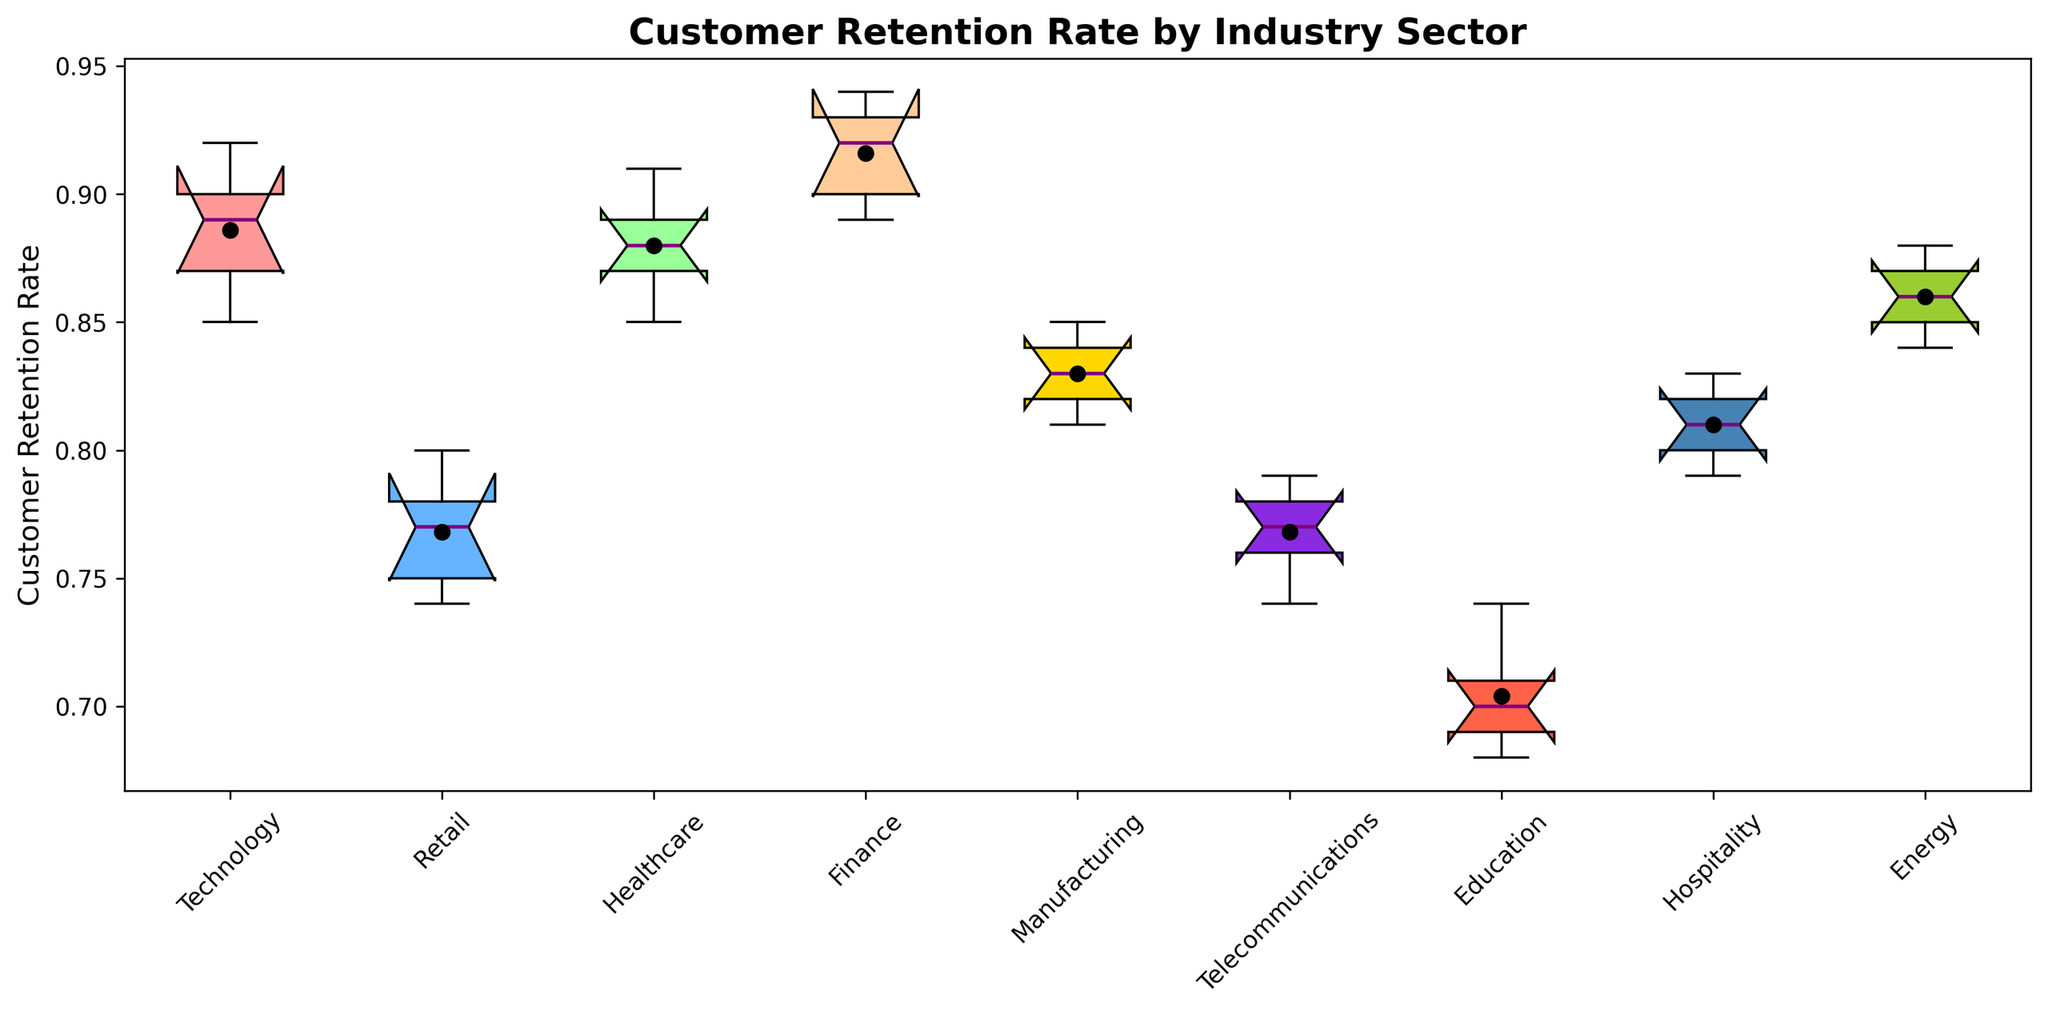what's the median customer retention rate for the Technology sector? Locate the box plot representing the Technology sector and find the line in the middle of the box; this line represents the median value.
Answer: 0.89 Which industry has the highest median customer retention rate? Compare the median lines (middle lines of each box) for all industries on the plot to identify the highest one.
Answer: Finance Are there any outliers in the customer retention rates for the Retail sector? Look for points outside the whiskers of the box plot for Retail; these points are considered outliers.
Answer: No Which industry has a larger spread in customer retention rates, Technology or Retail? Compare the interquartile range (height of the boxes) of the Technology and Retail box plots to determine which has a larger spread.
Answer: Technology For which industry is the mean customer retention rate higher than the median? Locate the mean points (black dots) and median lines for each industry and compare them to find where the mean is higher than the median.
Answer: Telecommunications What’s the range of customer retention rates for the Healthcare sector? Identify the minimum and maximum whiskers of the Healthcare box plot and subtract the minimum value from the maximum value.
Answer: 0.85-0.91 Compare the median customer retention rates between the Education and Hospitality sectors. Which is higher? Compare the median lines (middle lines of the boxes) of the Education and Hospitality sector box plots and identify which is higher.
Answer: Hospitality Which industry has the lowest range of customer retention rates? Compare the ranges (distance between the ends of the whiskers) of all the box plots and identify the smallest one.
Answer: Education 